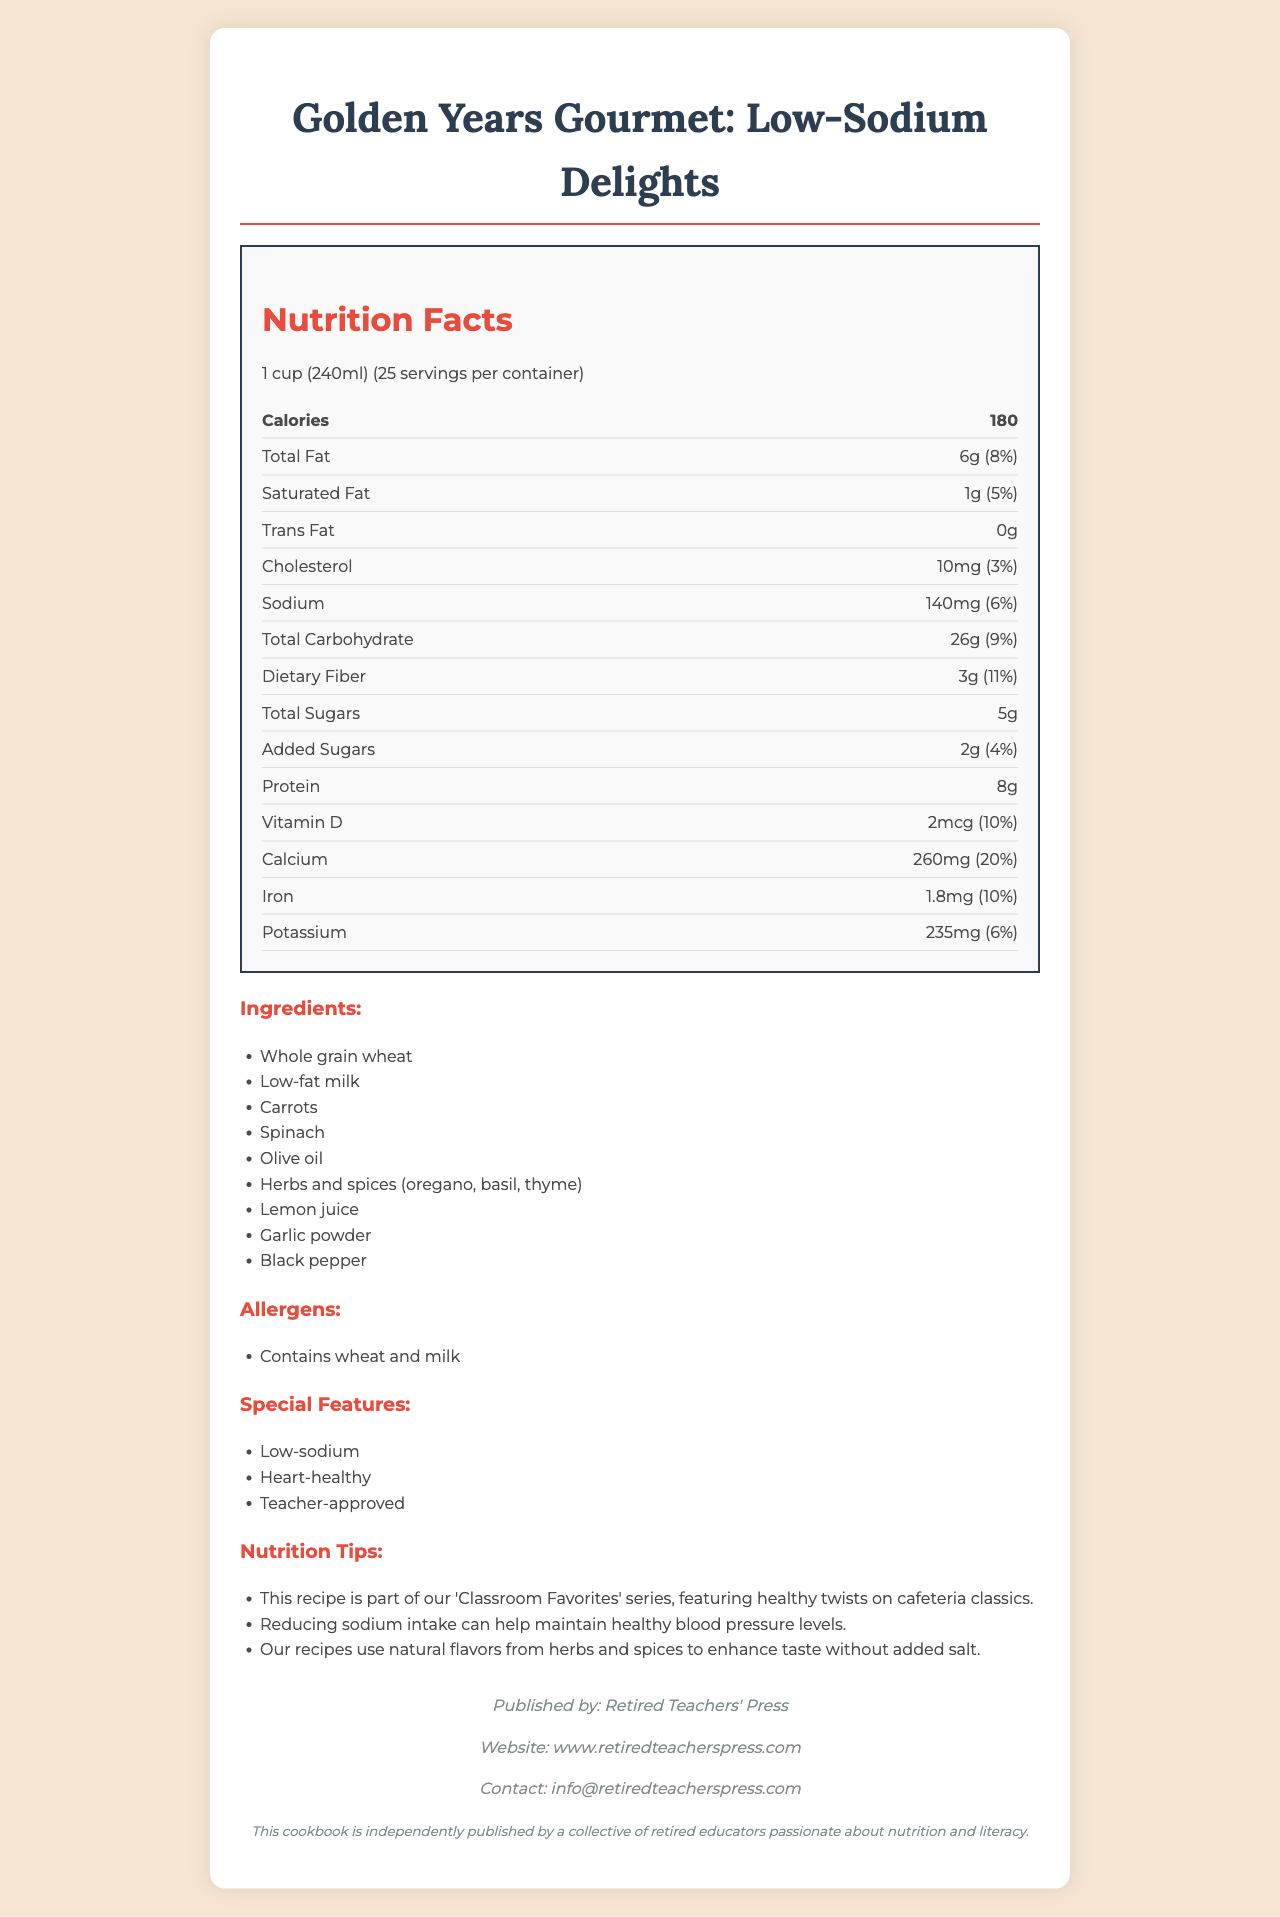what is the serving size? The serving size is specified at the beginning of the nutrition label section.
Answer: 1 cup (240ml) how many servings are in the container? The number of servings per container is listed as 25 in the nutrition label section.
Answer: 25 how many calories are in one serving? The calories per serving are 180, as indicated in the bold nutrition info section.
Answer: 180 what is the amount of dietary fiber per serving? The dietary fiber amount is listed as 3g in the nutrition info section.
Answer: 3g what are the two listed allergens? The allergens section mentions that the product contains wheat and milk.
Answer: wheat and milk how much calcium is in one serving? The calcium amount per serving is 260mg, as found in the nutrition label section.
Answer: 260mg does this product contain trans fat? The nutrition info section lists the amount of trans fat as 0g.
Answer: No which is not an ingredient in the recipe? A. Carrots B. Tomatoes C. Spinach The ingredients list includes carrots and spinach but not tomatoes.
Answer: B what is the daily value percentage of iron per serving? The nutrition label states the daily value percentage for iron as 10%.
Answer: 10% what is the main purpose of this cookbook? A. High-protein recipes B. Low-sodium options C. Keto diet The title and emphasis in the document focus on low-sodium options.
Answer: B is reducing sodium intake beneficial for blood pressure? The nutrition tips mention that reducing sodium intake can help maintain healthy blood pressure levels.
Answer: Yes name one feature of the cookbook that appeals to heart health The special features section lists "Heart-healthy" as one of the appeals.
Answer: Heart-healthy what is the contact email for Retired Teachers' Press? The publisher info section provides the contact email as info@retiredteacherspress.com.
Answer: info@retiredteacherspress.com summarize the main idea of the document The document provides comprehensive details about the nutritional content of the recipes, ingredients used, and the benefits of low-sodium diets. It also includes contact information for the publisher and highlights the self-publishing effort by retired educators.
Answer: This document is a nutrition facts label for "Golden Years Gourmet: Low-Sodium Delights," a self-published cookbook by retired teachers. The recipes prioritize low-sodium, heart-healthy options with teacher-approved ingredients and tips. The document includes detailed nutritional information, ingredients, special features, and publisher contact details. what is the total carbohydrate content including added sugars? The total carbohydrate is 26g, plus the added sugars amount is 2g, summing up to 28g.
Answer: 28g what percentage of the daily value of vitamin D does one serving provide? A. 6% B. 10% C. 20% The daily value percentage for vitamin D is listed as 10%.
Answer: B how much protein is in one serving? The amount of protein per serving is 8g, as indicated in the nutrition label section.
Answer: 8g which organization published the cookbook? The publisher info section at the bottom specifies that Retired Teachers' Press published the cookbook.
Answer: Retired Teachers' Press is the ingredient list free of any dairy products? The ingredients list includes low-fat milk, which is a dairy product.
Answer: No what specific benefits does the document claim regarding sodium intake? One of the nutrition tips states that reducing sodium intake can help maintain healthy blood pressure levels.
Answer: Maintains healthy blood pressure levels which spice is not mentioned as an ingredient? A. Oregano B. Cumin C. Thyme The listed herbs and spices include oregano, basil, and thyme, but not cumin.
Answer: B how many total fats and what percentage of daily value does it provide? The total fat content is 6g, which provides 8% of the daily value as per the nutrition label.
Answer: 6g, 8% 